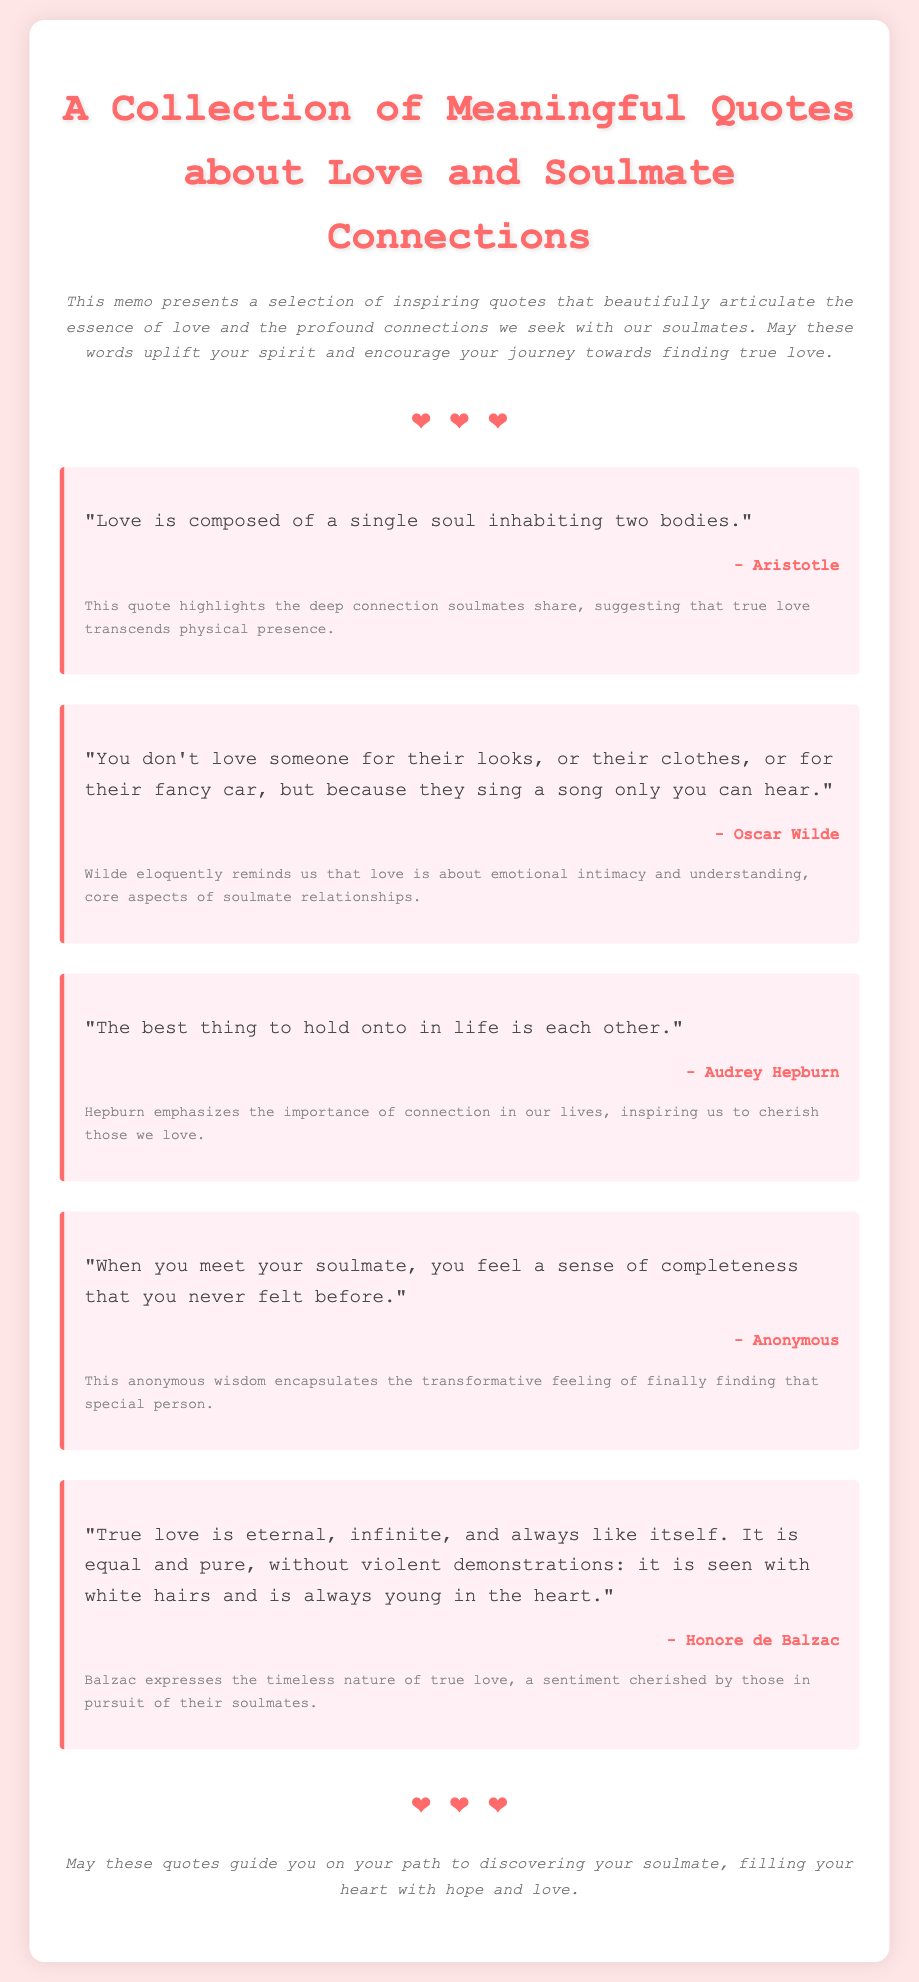What is the title of the collection? The title is the main heading that describes the content of the document.
Answer: A Collection of Meaningful Quotes about Love and Soulmate Connections Who is the author of the first quote? The author is mentioned directly below the quote in the quote-container.
Answer: Aristotle What does the second quote emphasize about love? This aspect is captured in the context provided after the quote, which emphasizes emotional intimacy.
Answer: Emotional intimacy How many quotes are included in the document? The document features a specific number of quotes.
Answer: Five What color is the background of the document? The background color is specified in the CSS style section of the document.
Answer: #ffe6e6 What symbol is used to represent love in the document? The symbol used is displayed prominently within the hearts section of the document.
Answer: ❤️ What does the closing statement suggest? The closing statement expresses the intent of the document regarding its effect on the reader's journey.
Answer: Guide you on your path to discovering your soulmate 